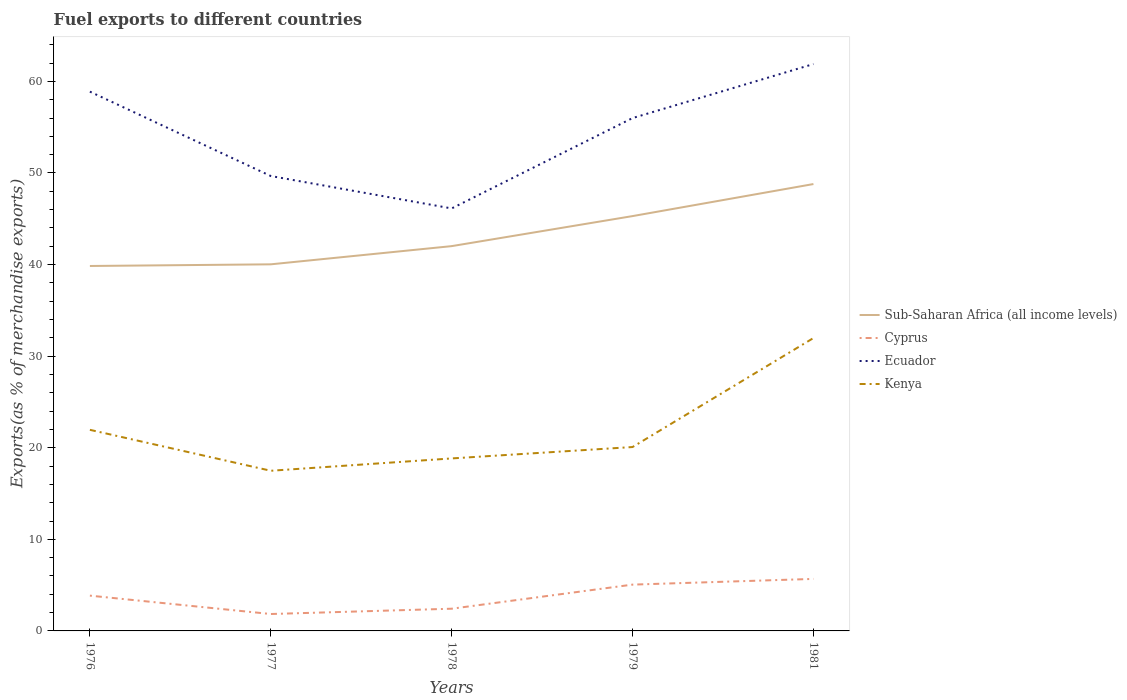How many different coloured lines are there?
Provide a succinct answer. 4. Does the line corresponding to Sub-Saharan Africa (all income levels) intersect with the line corresponding to Ecuador?
Offer a terse response. No. Across all years, what is the maximum percentage of exports to different countries in Sub-Saharan Africa (all income levels)?
Make the answer very short. 39.85. What is the total percentage of exports to different countries in Cyprus in the graph?
Ensure brevity in your answer.  -0.58. What is the difference between the highest and the second highest percentage of exports to different countries in Cyprus?
Keep it short and to the point. 3.83. What is the difference between the highest and the lowest percentage of exports to different countries in Kenya?
Keep it short and to the point. 1. Is the percentage of exports to different countries in Cyprus strictly greater than the percentage of exports to different countries in Ecuador over the years?
Make the answer very short. Yes. How many lines are there?
Your response must be concise. 4. What is the difference between two consecutive major ticks on the Y-axis?
Your answer should be compact. 10. Are the values on the major ticks of Y-axis written in scientific E-notation?
Give a very brief answer. No. Where does the legend appear in the graph?
Offer a terse response. Center right. How many legend labels are there?
Your answer should be very brief. 4. How are the legend labels stacked?
Your response must be concise. Vertical. What is the title of the graph?
Keep it short and to the point. Fuel exports to different countries. Does "Lebanon" appear as one of the legend labels in the graph?
Offer a very short reply. No. What is the label or title of the Y-axis?
Ensure brevity in your answer.  Exports(as % of merchandise exports). What is the Exports(as % of merchandise exports) of Sub-Saharan Africa (all income levels) in 1976?
Ensure brevity in your answer.  39.85. What is the Exports(as % of merchandise exports) of Cyprus in 1976?
Make the answer very short. 3.85. What is the Exports(as % of merchandise exports) in Ecuador in 1976?
Ensure brevity in your answer.  58.88. What is the Exports(as % of merchandise exports) in Kenya in 1976?
Your response must be concise. 21.96. What is the Exports(as % of merchandise exports) in Sub-Saharan Africa (all income levels) in 1977?
Provide a short and direct response. 40.03. What is the Exports(as % of merchandise exports) of Cyprus in 1977?
Ensure brevity in your answer.  1.85. What is the Exports(as % of merchandise exports) in Ecuador in 1977?
Your answer should be very brief. 49.67. What is the Exports(as % of merchandise exports) in Kenya in 1977?
Offer a very short reply. 17.49. What is the Exports(as % of merchandise exports) of Sub-Saharan Africa (all income levels) in 1978?
Your answer should be compact. 42.01. What is the Exports(as % of merchandise exports) of Cyprus in 1978?
Offer a terse response. 2.43. What is the Exports(as % of merchandise exports) in Ecuador in 1978?
Your response must be concise. 46.13. What is the Exports(as % of merchandise exports) of Kenya in 1978?
Your answer should be compact. 18.83. What is the Exports(as % of merchandise exports) in Sub-Saharan Africa (all income levels) in 1979?
Ensure brevity in your answer.  45.29. What is the Exports(as % of merchandise exports) in Cyprus in 1979?
Offer a terse response. 5.06. What is the Exports(as % of merchandise exports) of Ecuador in 1979?
Your response must be concise. 55.99. What is the Exports(as % of merchandise exports) of Kenya in 1979?
Provide a short and direct response. 20.08. What is the Exports(as % of merchandise exports) in Sub-Saharan Africa (all income levels) in 1981?
Your answer should be compact. 48.79. What is the Exports(as % of merchandise exports) of Cyprus in 1981?
Provide a succinct answer. 5.68. What is the Exports(as % of merchandise exports) of Ecuador in 1981?
Offer a very short reply. 61.89. What is the Exports(as % of merchandise exports) of Kenya in 1981?
Give a very brief answer. 31.98. Across all years, what is the maximum Exports(as % of merchandise exports) in Sub-Saharan Africa (all income levels)?
Your response must be concise. 48.79. Across all years, what is the maximum Exports(as % of merchandise exports) of Cyprus?
Provide a succinct answer. 5.68. Across all years, what is the maximum Exports(as % of merchandise exports) in Ecuador?
Give a very brief answer. 61.89. Across all years, what is the maximum Exports(as % of merchandise exports) of Kenya?
Ensure brevity in your answer.  31.98. Across all years, what is the minimum Exports(as % of merchandise exports) of Sub-Saharan Africa (all income levels)?
Your answer should be compact. 39.85. Across all years, what is the minimum Exports(as % of merchandise exports) in Cyprus?
Provide a short and direct response. 1.85. Across all years, what is the minimum Exports(as % of merchandise exports) of Ecuador?
Your answer should be very brief. 46.13. Across all years, what is the minimum Exports(as % of merchandise exports) in Kenya?
Give a very brief answer. 17.49. What is the total Exports(as % of merchandise exports) of Sub-Saharan Africa (all income levels) in the graph?
Keep it short and to the point. 215.97. What is the total Exports(as % of merchandise exports) of Cyprus in the graph?
Ensure brevity in your answer.  18.86. What is the total Exports(as % of merchandise exports) in Ecuador in the graph?
Your response must be concise. 272.56. What is the total Exports(as % of merchandise exports) of Kenya in the graph?
Offer a very short reply. 110.33. What is the difference between the Exports(as % of merchandise exports) in Sub-Saharan Africa (all income levels) in 1976 and that in 1977?
Ensure brevity in your answer.  -0.18. What is the difference between the Exports(as % of merchandise exports) in Cyprus in 1976 and that in 1977?
Make the answer very short. 2.01. What is the difference between the Exports(as % of merchandise exports) in Ecuador in 1976 and that in 1977?
Offer a terse response. 9.21. What is the difference between the Exports(as % of merchandise exports) of Kenya in 1976 and that in 1977?
Provide a succinct answer. 4.47. What is the difference between the Exports(as % of merchandise exports) in Sub-Saharan Africa (all income levels) in 1976 and that in 1978?
Offer a terse response. -2.17. What is the difference between the Exports(as % of merchandise exports) of Cyprus in 1976 and that in 1978?
Make the answer very short. 1.43. What is the difference between the Exports(as % of merchandise exports) of Ecuador in 1976 and that in 1978?
Give a very brief answer. 12.75. What is the difference between the Exports(as % of merchandise exports) in Kenya in 1976 and that in 1978?
Offer a terse response. 3.12. What is the difference between the Exports(as % of merchandise exports) in Sub-Saharan Africa (all income levels) in 1976 and that in 1979?
Ensure brevity in your answer.  -5.45. What is the difference between the Exports(as % of merchandise exports) of Cyprus in 1976 and that in 1979?
Ensure brevity in your answer.  -1.2. What is the difference between the Exports(as % of merchandise exports) in Ecuador in 1976 and that in 1979?
Keep it short and to the point. 2.89. What is the difference between the Exports(as % of merchandise exports) in Kenya in 1976 and that in 1979?
Keep it short and to the point. 1.88. What is the difference between the Exports(as % of merchandise exports) in Sub-Saharan Africa (all income levels) in 1976 and that in 1981?
Your response must be concise. -8.95. What is the difference between the Exports(as % of merchandise exports) in Cyprus in 1976 and that in 1981?
Keep it short and to the point. -1.83. What is the difference between the Exports(as % of merchandise exports) in Ecuador in 1976 and that in 1981?
Offer a very short reply. -3.01. What is the difference between the Exports(as % of merchandise exports) in Kenya in 1976 and that in 1981?
Your answer should be compact. -10.02. What is the difference between the Exports(as % of merchandise exports) in Sub-Saharan Africa (all income levels) in 1977 and that in 1978?
Offer a very short reply. -1.99. What is the difference between the Exports(as % of merchandise exports) of Cyprus in 1977 and that in 1978?
Offer a terse response. -0.58. What is the difference between the Exports(as % of merchandise exports) in Ecuador in 1977 and that in 1978?
Your answer should be compact. 3.54. What is the difference between the Exports(as % of merchandise exports) in Kenya in 1977 and that in 1978?
Offer a very short reply. -1.35. What is the difference between the Exports(as % of merchandise exports) in Sub-Saharan Africa (all income levels) in 1977 and that in 1979?
Offer a terse response. -5.27. What is the difference between the Exports(as % of merchandise exports) in Cyprus in 1977 and that in 1979?
Provide a succinct answer. -3.21. What is the difference between the Exports(as % of merchandise exports) in Ecuador in 1977 and that in 1979?
Your answer should be very brief. -6.33. What is the difference between the Exports(as % of merchandise exports) in Kenya in 1977 and that in 1979?
Give a very brief answer. -2.59. What is the difference between the Exports(as % of merchandise exports) in Sub-Saharan Africa (all income levels) in 1977 and that in 1981?
Provide a short and direct response. -8.76. What is the difference between the Exports(as % of merchandise exports) of Cyprus in 1977 and that in 1981?
Keep it short and to the point. -3.83. What is the difference between the Exports(as % of merchandise exports) of Ecuador in 1977 and that in 1981?
Your answer should be very brief. -12.22. What is the difference between the Exports(as % of merchandise exports) in Kenya in 1977 and that in 1981?
Make the answer very short. -14.49. What is the difference between the Exports(as % of merchandise exports) in Sub-Saharan Africa (all income levels) in 1978 and that in 1979?
Your response must be concise. -3.28. What is the difference between the Exports(as % of merchandise exports) in Cyprus in 1978 and that in 1979?
Provide a short and direct response. -2.63. What is the difference between the Exports(as % of merchandise exports) in Ecuador in 1978 and that in 1979?
Offer a terse response. -9.87. What is the difference between the Exports(as % of merchandise exports) of Kenya in 1978 and that in 1979?
Your answer should be compact. -1.24. What is the difference between the Exports(as % of merchandise exports) in Sub-Saharan Africa (all income levels) in 1978 and that in 1981?
Ensure brevity in your answer.  -6.78. What is the difference between the Exports(as % of merchandise exports) in Cyprus in 1978 and that in 1981?
Your answer should be compact. -3.25. What is the difference between the Exports(as % of merchandise exports) of Ecuador in 1978 and that in 1981?
Give a very brief answer. -15.76. What is the difference between the Exports(as % of merchandise exports) in Kenya in 1978 and that in 1981?
Provide a succinct answer. -13.14. What is the difference between the Exports(as % of merchandise exports) in Sub-Saharan Africa (all income levels) in 1979 and that in 1981?
Ensure brevity in your answer.  -3.5. What is the difference between the Exports(as % of merchandise exports) in Cyprus in 1979 and that in 1981?
Provide a succinct answer. -0.62. What is the difference between the Exports(as % of merchandise exports) in Ecuador in 1979 and that in 1981?
Make the answer very short. -5.9. What is the difference between the Exports(as % of merchandise exports) in Kenya in 1979 and that in 1981?
Ensure brevity in your answer.  -11.9. What is the difference between the Exports(as % of merchandise exports) of Sub-Saharan Africa (all income levels) in 1976 and the Exports(as % of merchandise exports) of Cyprus in 1977?
Ensure brevity in your answer.  38. What is the difference between the Exports(as % of merchandise exports) of Sub-Saharan Africa (all income levels) in 1976 and the Exports(as % of merchandise exports) of Ecuador in 1977?
Offer a very short reply. -9.82. What is the difference between the Exports(as % of merchandise exports) of Sub-Saharan Africa (all income levels) in 1976 and the Exports(as % of merchandise exports) of Kenya in 1977?
Provide a short and direct response. 22.36. What is the difference between the Exports(as % of merchandise exports) of Cyprus in 1976 and the Exports(as % of merchandise exports) of Ecuador in 1977?
Give a very brief answer. -45.81. What is the difference between the Exports(as % of merchandise exports) in Cyprus in 1976 and the Exports(as % of merchandise exports) in Kenya in 1977?
Your response must be concise. -13.63. What is the difference between the Exports(as % of merchandise exports) in Ecuador in 1976 and the Exports(as % of merchandise exports) in Kenya in 1977?
Your answer should be compact. 41.39. What is the difference between the Exports(as % of merchandise exports) in Sub-Saharan Africa (all income levels) in 1976 and the Exports(as % of merchandise exports) in Cyprus in 1978?
Your response must be concise. 37.42. What is the difference between the Exports(as % of merchandise exports) in Sub-Saharan Africa (all income levels) in 1976 and the Exports(as % of merchandise exports) in Ecuador in 1978?
Provide a succinct answer. -6.28. What is the difference between the Exports(as % of merchandise exports) of Sub-Saharan Africa (all income levels) in 1976 and the Exports(as % of merchandise exports) of Kenya in 1978?
Your response must be concise. 21.01. What is the difference between the Exports(as % of merchandise exports) of Cyprus in 1976 and the Exports(as % of merchandise exports) of Ecuador in 1978?
Provide a short and direct response. -42.27. What is the difference between the Exports(as % of merchandise exports) of Cyprus in 1976 and the Exports(as % of merchandise exports) of Kenya in 1978?
Make the answer very short. -14.98. What is the difference between the Exports(as % of merchandise exports) of Ecuador in 1976 and the Exports(as % of merchandise exports) of Kenya in 1978?
Provide a succinct answer. 40.05. What is the difference between the Exports(as % of merchandise exports) of Sub-Saharan Africa (all income levels) in 1976 and the Exports(as % of merchandise exports) of Cyprus in 1979?
Make the answer very short. 34.79. What is the difference between the Exports(as % of merchandise exports) in Sub-Saharan Africa (all income levels) in 1976 and the Exports(as % of merchandise exports) in Ecuador in 1979?
Provide a short and direct response. -16.15. What is the difference between the Exports(as % of merchandise exports) in Sub-Saharan Africa (all income levels) in 1976 and the Exports(as % of merchandise exports) in Kenya in 1979?
Give a very brief answer. 19.77. What is the difference between the Exports(as % of merchandise exports) in Cyprus in 1976 and the Exports(as % of merchandise exports) in Ecuador in 1979?
Keep it short and to the point. -52.14. What is the difference between the Exports(as % of merchandise exports) of Cyprus in 1976 and the Exports(as % of merchandise exports) of Kenya in 1979?
Your answer should be compact. -16.23. What is the difference between the Exports(as % of merchandise exports) of Ecuador in 1976 and the Exports(as % of merchandise exports) of Kenya in 1979?
Provide a succinct answer. 38.8. What is the difference between the Exports(as % of merchandise exports) in Sub-Saharan Africa (all income levels) in 1976 and the Exports(as % of merchandise exports) in Cyprus in 1981?
Your response must be concise. 34.17. What is the difference between the Exports(as % of merchandise exports) of Sub-Saharan Africa (all income levels) in 1976 and the Exports(as % of merchandise exports) of Ecuador in 1981?
Your answer should be compact. -22.04. What is the difference between the Exports(as % of merchandise exports) in Sub-Saharan Africa (all income levels) in 1976 and the Exports(as % of merchandise exports) in Kenya in 1981?
Offer a very short reply. 7.87. What is the difference between the Exports(as % of merchandise exports) of Cyprus in 1976 and the Exports(as % of merchandise exports) of Ecuador in 1981?
Make the answer very short. -58.04. What is the difference between the Exports(as % of merchandise exports) of Cyprus in 1976 and the Exports(as % of merchandise exports) of Kenya in 1981?
Your response must be concise. -28.12. What is the difference between the Exports(as % of merchandise exports) of Ecuador in 1976 and the Exports(as % of merchandise exports) of Kenya in 1981?
Your answer should be compact. 26.9. What is the difference between the Exports(as % of merchandise exports) in Sub-Saharan Africa (all income levels) in 1977 and the Exports(as % of merchandise exports) in Cyprus in 1978?
Keep it short and to the point. 37.6. What is the difference between the Exports(as % of merchandise exports) of Sub-Saharan Africa (all income levels) in 1977 and the Exports(as % of merchandise exports) of Ecuador in 1978?
Your answer should be very brief. -6.1. What is the difference between the Exports(as % of merchandise exports) of Sub-Saharan Africa (all income levels) in 1977 and the Exports(as % of merchandise exports) of Kenya in 1978?
Keep it short and to the point. 21.19. What is the difference between the Exports(as % of merchandise exports) of Cyprus in 1977 and the Exports(as % of merchandise exports) of Ecuador in 1978?
Make the answer very short. -44.28. What is the difference between the Exports(as % of merchandise exports) in Cyprus in 1977 and the Exports(as % of merchandise exports) in Kenya in 1978?
Make the answer very short. -16.99. What is the difference between the Exports(as % of merchandise exports) in Ecuador in 1977 and the Exports(as % of merchandise exports) in Kenya in 1978?
Ensure brevity in your answer.  30.83. What is the difference between the Exports(as % of merchandise exports) in Sub-Saharan Africa (all income levels) in 1977 and the Exports(as % of merchandise exports) in Cyprus in 1979?
Your answer should be very brief. 34.97. What is the difference between the Exports(as % of merchandise exports) in Sub-Saharan Africa (all income levels) in 1977 and the Exports(as % of merchandise exports) in Ecuador in 1979?
Give a very brief answer. -15.97. What is the difference between the Exports(as % of merchandise exports) of Sub-Saharan Africa (all income levels) in 1977 and the Exports(as % of merchandise exports) of Kenya in 1979?
Make the answer very short. 19.95. What is the difference between the Exports(as % of merchandise exports) in Cyprus in 1977 and the Exports(as % of merchandise exports) in Ecuador in 1979?
Provide a succinct answer. -54.15. What is the difference between the Exports(as % of merchandise exports) in Cyprus in 1977 and the Exports(as % of merchandise exports) in Kenya in 1979?
Ensure brevity in your answer.  -18.23. What is the difference between the Exports(as % of merchandise exports) of Ecuador in 1977 and the Exports(as % of merchandise exports) of Kenya in 1979?
Make the answer very short. 29.59. What is the difference between the Exports(as % of merchandise exports) of Sub-Saharan Africa (all income levels) in 1977 and the Exports(as % of merchandise exports) of Cyprus in 1981?
Your answer should be very brief. 34.35. What is the difference between the Exports(as % of merchandise exports) of Sub-Saharan Africa (all income levels) in 1977 and the Exports(as % of merchandise exports) of Ecuador in 1981?
Provide a succinct answer. -21.86. What is the difference between the Exports(as % of merchandise exports) of Sub-Saharan Africa (all income levels) in 1977 and the Exports(as % of merchandise exports) of Kenya in 1981?
Ensure brevity in your answer.  8.05. What is the difference between the Exports(as % of merchandise exports) of Cyprus in 1977 and the Exports(as % of merchandise exports) of Ecuador in 1981?
Your answer should be compact. -60.04. What is the difference between the Exports(as % of merchandise exports) in Cyprus in 1977 and the Exports(as % of merchandise exports) in Kenya in 1981?
Your answer should be very brief. -30.13. What is the difference between the Exports(as % of merchandise exports) of Ecuador in 1977 and the Exports(as % of merchandise exports) of Kenya in 1981?
Ensure brevity in your answer.  17.69. What is the difference between the Exports(as % of merchandise exports) in Sub-Saharan Africa (all income levels) in 1978 and the Exports(as % of merchandise exports) in Cyprus in 1979?
Your response must be concise. 36.96. What is the difference between the Exports(as % of merchandise exports) in Sub-Saharan Africa (all income levels) in 1978 and the Exports(as % of merchandise exports) in Ecuador in 1979?
Your answer should be very brief. -13.98. What is the difference between the Exports(as % of merchandise exports) in Sub-Saharan Africa (all income levels) in 1978 and the Exports(as % of merchandise exports) in Kenya in 1979?
Your answer should be compact. 21.93. What is the difference between the Exports(as % of merchandise exports) in Cyprus in 1978 and the Exports(as % of merchandise exports) in Ecuador in 1979?
Your answer should be very brief. -53.57. What is the difference between the Exports(as % of merchandise exports) of Cyprus in 1978 and the Exports(as % of merchandise exports) of Kenya in 1979?
Offer a very short reply. -17.65. What is the difference between the Exports(as % of merchandise exports) in Ecuador in 1978 and the Exports(as % of merchandise exports) in Kenya in 1979?
Offer a terse response. 26.05. What is the difference between the Exports(as % of merchandise exports) in Sub-Saharan Africa (all income levels) in 1978 and the Exports(as % of merchandise exports) in Cyprus in 1981?
Give a very brief answer. 36.33. What is the difference between the Exports(as % of merchandise exports) in Sub-Saharan Africa (all income levels) in 1978 and the Exports(as % of merchandise exports) in Ecuador in 1981?
Provide a short and direct response. -19.88. What is the difference between the Exports(as % of merchandise exports) in Sub-Saharan Africa (all income levels) in 1978 and the Exports(as % of merchandise exports) in Kenya in 1981?
Your response must be concise. 10.04. What is the difference between the Exports(as % of merchandise exports) of Cyprus in 1978 and the Exports(as % of merchandise exports) of Ecuador in 1981?
Make the answer very short. -59.46. What is the difference between the Exports(as % of merchandise exports) of Cyprus in 1978 and the Exports(as % of merchandise exports) of Kenya in 1981?
Provide a short and direct response. -29.55. What is the difference between the Exports(as % of merchandise exports) in Ecuador in 1978 and the Exports(as % of merchandise exports) in Kenya in 1981?
Offer a terse response. 14.15. What is the difference between the Exports(as % of merchandise exports) of Sub-Saharan Africa (all income levels) in 1979 and the Exports(as % of merchandise exports) of Cyprus in 1981?
Your answer should be compact. 39.61. What is the difference between the Exports(as % of merchandise exports) of Sub-Saharan Africa (all income levels) in 1979 and the Exports(as % of merchandise exports) of Ecuador in 1981?
Your answer should be very brief. -16.6. What is the difference between the Exports(as % of merchandise exports) of Sub-Saharan Africa (all income levels) in 1979 and the Exports(as % of merchandise exports) of Kenya in 1981?
Your answer should be very brief. 13.32. What is the difference between the Exports(as % of merchandise exports) of Cyprus in 1979 and the Exports(as % of merchandise exports) of Ecuador in 1981?
Ensure brevity in your answer.  -56.83. What is the difference between the Exports(as % of merchandise exports) in Cyprus in 1979 and the Exports(as % of merchandise exports) in Kenya in 1981?
Offer a very short reply. -26.92. What is the difference between the Exports(as % of merchandise exports) in Ecuador in 1979 and the Exports(as % of merchandise exports) in Kenya in 1981?
Offer a very short reply. 24.02. What is the average Exports(as % of merchandise exports) in Sub-Saharan Africa (all income levels) per year?
Provide a succinct answer. 43.19. What is the average Exports(as % of merchandise exports) in Cyprus per year?
Offer a very short reply. 3.77. What is the average Exports(as % of merchandise exports) of Ecuador per year?
Keep it short and to the point. 54.51. What is the average Exports(as % of merchandise exports) of Kenya per year?
Keep it short and to the point. 22.07. In the year 1976, what is the difference between the Exports(as % of merchandise exports) in Sub-Saharan Africa (all income levels) and Exports(as % of merchandise exports) in Cyprus?
Make the answer very short. 35.99. In the year 1976, what is the difference between the Exports(as % of merchandise exports) of Sub-Saharan Africa (all income levels) and Exports(as % of merchandise exports) of Ecuador?
Provide a short and direct response. -19.04. In the year 1976, what is the difference between the Exports(as % of merchandise exports) of Sub-Saharan Africa (all income levels) and Exports(as % of merchandise exports) of Kenya?
Make the answer very short. 17.89. In the year 1976, what is the difference between the Exports(as % of merchandise exports) of Cyprus and Exports(as % of merchandise exports) of Ecuador?
Offer a very short reply. -55.03. In the year 1976, what is the difference between the Exports(as % of merchandise exports) of Cyprus and Exports(as % of merchandise exports) of Kenya?
Offer a terse response. -18.1. In the year 1976, what is the difference between the Exports(as % of merchandise exports) in Ecuador and Exports(as % of merchandise exports) in Kenya?
Provide a succinct answer. 36.92. In the year 1977, what is the difference between the Exports(as % of merchandise exports) of Sub-Saharan Africa (all income levels) and Exports(as % of merchandise exports) of Cyprus?
Offer a very short reply. 38.18. In the year 1977, what is the difference between the Exports(as % of merchandise exports) in Sub-Saharan Africa (all income levels) and Exports(as % of merchandise exports) in Ecuador?
Keep it short and to the point. -9.64. In the year 1977, what is the difference between the Exports(as % of merchandise exports) of Sub-Saharan Africa (all income levels) and Exports(as % of merchandise exports) of Kenya?
Provide a short and direct response. 22.54. In the year 1977, what is the difference between the Exports(as % of merchandise exports) of Cyprus and Exports(as % of merchandise exports) of Ecuador?
Offer a terse response. -47.82. In the year 1977, what is the difference between the Exports(as % of merchandise exports) of Cyprus and Exports(as % of merchandise exports) of Kenya?
Make the answer very short. -15.64. In the year 1977, what is the difference between the Exports(as % of merchandise exports) of Ecuador and Exports(as % of merchandise exports) of Kenya?
Give a very brief answer. 32.18. In the year 1978, what is the difference between the Exports(as % of merchandise exports) in Sub-Saharan Africa (all income levels) and Exports(as % of merchandise exports) in Cyprus?
Your response must be concise. 39.59. In the year 1978, what is the difference between the Exports(as % of merchandise exports) of Sub-Saharan Africa (all income levels) and Exports(as % of merchandise exports) of Ecuador?
Your answer should be very brief. -4.12. In the year 1978, what is the difference between the Exports(as % of merchandise exports) of Sub-Saharan Africa (all income levels) and Exports(as % of merchandise exports) of Kenya?
Keep it short and to the point. 23.18. In the year 1978, what is the difference between the Exports(as % of merchandise exports) of Cyprus and Exports(as % of merchandise exports) of Ecuador?
Make the answer very short. -43.7. In the year 1978, what is the difference between the Exports(as % of merchandise exports) of Cyprus and Exports(as % of merchandise exports) of Kenya?
Keep it short and to the point. -16.41. In the year 1978, what is the difference between the Exports(as % of merchandise exports) of Ecuador and Exports(as % of merchandise exports) of Kenya?
Ensure brevity in your answer.  27.29. In the year 1979, what is the difference between the Exports(as % of merchandise exports) in Sub-Saharan Africa (all income levels) and Exports(as % of merchandise exports) in Cyprus?
Offer a terse response. 40.24. In the year 1979, what is the difference between the Exports(as % of merchandise exports) in Sub-Saharan Africa (all income levels) and Exports(as % of merchandise exports) in Ecuador?
Make the answer very short. -10.7. In the year 1979, what is the difference between the Exports(as % of merchandise exports) in Sub-Saharan Africa (all income levels) and Exports(as % of merchandise exports) in Kenya?
Your answer should be compact. 25.21. In the year 1979, what is the difference between the Exports(as % of merchandise exports) of Cyprus and Exports(as % of merchandise exports) of Ecuador?
Make the answer very short. -50.94. In the year 1979, what is the difference between the Exports(as % of merchandise exports) of Cyprus and Exports(as % of merchandise exports) of Kenya?
Offer a very short reply. -15.02. In the year 1979, what is the difference between the Exports(as % of merchandise exports) in Ecuador and Exports(as % of merchandise exports) in Kenya?
Your answer should be very brief. 35.92. In the year 1981, what is the difference between the Exports(as % of merchandise exports) in Sub-Saharan Africa (all income levels) and Exports(as % of merchandise exports) in Cyprus?
Keep it short and to the point. 43.11. In the year 1981, what is the difference between the Exports(as % of merchandise exports) in Sub-Saharan Africa (all income levels) and Exports(as % of merchandise exports) in Ecuador?
Make the answer very short. -13.1. In the year 1981, what is the difference between the Exports(as % of merchandise exports) in Sub-Saharan Africa (all income levels) and Exports(as % of merchandise exports) in Kenya?
Your answer should be compact. 16.81. In the year 1981, what is the difference between the Exports(as % of merchandise exports) of Cyprus and Exports(as % of merchandise exports) of Ecuador?
Your answer should be compact. -56.21. In the year 1981, what is the difference between the Exports(as % of merchandise exports) in Cyprus and Exports(as % of merchandise exports) in Kenya?
Provide a short and direct response. -26.3. In the year 1981, what is the difference between the Exports(as % of merchandise exports) in Ecuador and Exports(as % of merchandise exports) in Kenya?
Your answer should be very brief. 29.91. What is the ratio of the Exports(as % of merchandise exports) of Cyprus in 1976 to that in 1977?
Offer a terse response. 2.09. What is the ratio of the Exports(as % of merchandise exports) of Ecuador in 1976 to that in 1977?
Provide a short and direct response. 1.19. What is the ratio of the Exports(as % of merchandise exports) in Kenya in 1976 to that in 1977?
Your answer should be compact. 1.26. What is the ratio of the Exports(as % of merchandise exports) of Sub-Saharan Africa (all income levels) in 1976 to that in 1978?
Ensure brevity in your answer.  0.95. What is the ratio of the Exports(as % of merchandise exports) of Cyprus in 1976 to that in 1978?
Provide a short and direct response. 1.59. What is the ratio of the Exports(as % of merchandise exports) of Ecuador in 1976 to that in 1978?
Your answer should be very brief. 1.28. What is the ratio of the Exports(as % of merchandise exports) in Kenya in 1976 to that in 1978?
Keep it short and to the point. 1.17. What is the ratio of the Exports(as % of merchandise exports) of Sub-Saharan Africa (all income levels) in 1976 to that in 1979?
Provide a succinct answer. 0.88. What is the ratio of the Exports(as % of merchandise exports) in Cyprus in 1976 to that in 1979?
Your response must be concise. 0.76. What is the ratio of the Exports(as % of merchandise exports) in Ecuador in 1976 to that in 1979?
Offer a terse response. 1.05. What is the ratio of the Exports(as % of merchandise exports) of Kenya in 1976 to that in 1979?
Offer a terse response. 1.09. What is the ratio of the Exports(as % of merchandise exports) in Sub-Saharan Africa (all income levels) in 1976 to that in 1981?
Make the answer very short. 0.82. What is the ratio of the Exports(as % of merchandise exports) in Cyprus in 1976 to that in 1981?
Give a very brief answer. 0.68. What is the ratio of the Exports(as % of merchandise exports) of Ecuador in 1976 to that in 1981?
Offer a terse response. 0.95. What is the ratio of the Exports(as % of merchandise exports) in Kenya in 1976 to that in 1981?
Offer a terse response. 0.69. What is the ratio of the Exports(as % of merchandise exports) of Sub-Saharan Africa (all income levels) in 1977 to that in 1978?
Give a very brief answer. 0.95. What is the ratio of the Exports(as % of merchandise exports) of Cyprus in 1977 to that in 1978?
Your answer should be very brief. 0.76. What is the ratio of the Exports(as % of merchandise exports) of Ecuador in 1977 to that in 1978?
Your response must be concise. 1.08. What is the ratio of the Exports(as % of merchandise exports) of Kenya in 1977 to that in 1978?
Offer a terse response. 0.93. What is the ratio of the Exports(as % of merchandise exports) of Sub-Saharan Africa (all income levels) in 1977 to that in 1979?
Give a very brief answer. 0.88. What is the ratio of the Exports(as % of merchandise exports) in Cyprus in 1977 to that in 1979?
Keep it short and to the point. 0.37. What is the ratio of the Exports(as % of merchandise exports) in Ecuador in 1977 to that in 1979?
Provide a succinct answer. 0.89. What is the ratio of the Exports(as % of merchandise exports) in Kenya in 1977 to that in 1979?
Give a very brief answer. 0.87. What is the ratio of the Exports(as % of merchandise exports) of Sub-Saharan Africa (all income levels) in 1977 to that in 1981?
Your answer should be very brief. 0.82. What is the ratio of the Exports(as % of merchandise exports) of Cyprus in 1977 to that in 1981?
Your answer should be very brief. 0.33. What is the ratio of the Exports(as % of merchandise exports) of Ecuador in 1977 to that in 1981?
Ensure brevity in your answer.  0.8. What is the ratio of the Exports(as % of merchandise exports) in Kenya in 1977 to that in 1981?
Provide a short and direct response. 0.55. What is the ratio of the Exports(as % of merchandise exports) of Sub-Saharan Africa (all income levels) in 1978 to that in 1979?
Offer a terse response. 0.93. What is the ratio of the Exports(as % of merchandise exports) in Cyprus in 1978 to that in 1979?
Offer a very short reply. 0.48. What is the ratio of the Exports(as % of merchandise exports) of Ecuador in 1978 to that in 1979?
Make the answer very short. 0.82. What is the ratio of the Exports(as % of merchandise exports) of Kenya in 1978 to that in 1979?
Keep it short and to the point. 0.94. What is the ratio of the Exports(as % of merchandise exports) in Sub-Saharan Africa (all income levels) in 1978 to that in 1981?
Offer a very short reply. 0.86. What is the ratio of the Exports(as % of merchandise exports) in Cyprus in 1978 to that in 1981?
Your response must be concise. 0.43. What is the ratio of the Exports(as % of merchandise exports) of Ecuador in 1978 to that in 1981?
Give a very brief answer. 0.75. What is the ratio of the Exports(as % of merchandise exports) in Kenya in 1978 to that in 1981?
Offer a terse response. 0.59. What is the ratio of the Exports(as % of merchandise exports) of Sub-Saharan Africa (all income levels) in 1979 to that in 1981?
Provide a succinct answer. 0.93. What is the ratio of the Exports(as % of merchandise exports) of Cyprus in 1979 to that in 1981?
Provide a succinct answer. 0.89. What is the ratio of the Exports(as % of merchandise exports) of Ecuador in 1979 to that in 1981?
Ensure brevity in your answer.  0.9. What is the ratio of the Exports(as % of merchandise exports) in Kenya in 1979 to that in 1981?
Keep it short and to the point. 0.63. What is the difference between the highest and the second highest Exports(as % of merchandise exports) in Sub-Saharan Africa (all income levels)?
Provide a succinct answer. 3.5. What is the difference between the highest and the second highest Exports(as % of merchandise exports) in Cyprus?
Make the answer very short. 0.62. What is the difference between the highest and the second highest Exports(as % of merchandise exports) of Ecuador?
Make the answer very short. 3.01. What is the difference between the highest and the second highest Exports(as % of merchandise exports) in Kenya?
Offer a very short reply. 10.02. What is the difference between the highest and the lowest Exports(as % of merchandise exports) of Sub-Saharan Africa (all income levels)?
Your answer should be very brief. 8.95. What is the difference between the highest and the lowest Exports(as % of merchandise exports) in Cyprus?
Give a very brief answer. 3.83. What is the difference between the highest and the lowest Exports(as % of merchandise exports) of Ecuador?
Ensure brevity in your answer.  15.76. What is the difference between the highest and the lowest Exports(as % of merchandise exports) in Kenya?
Your answer should be compact. 14.49. 